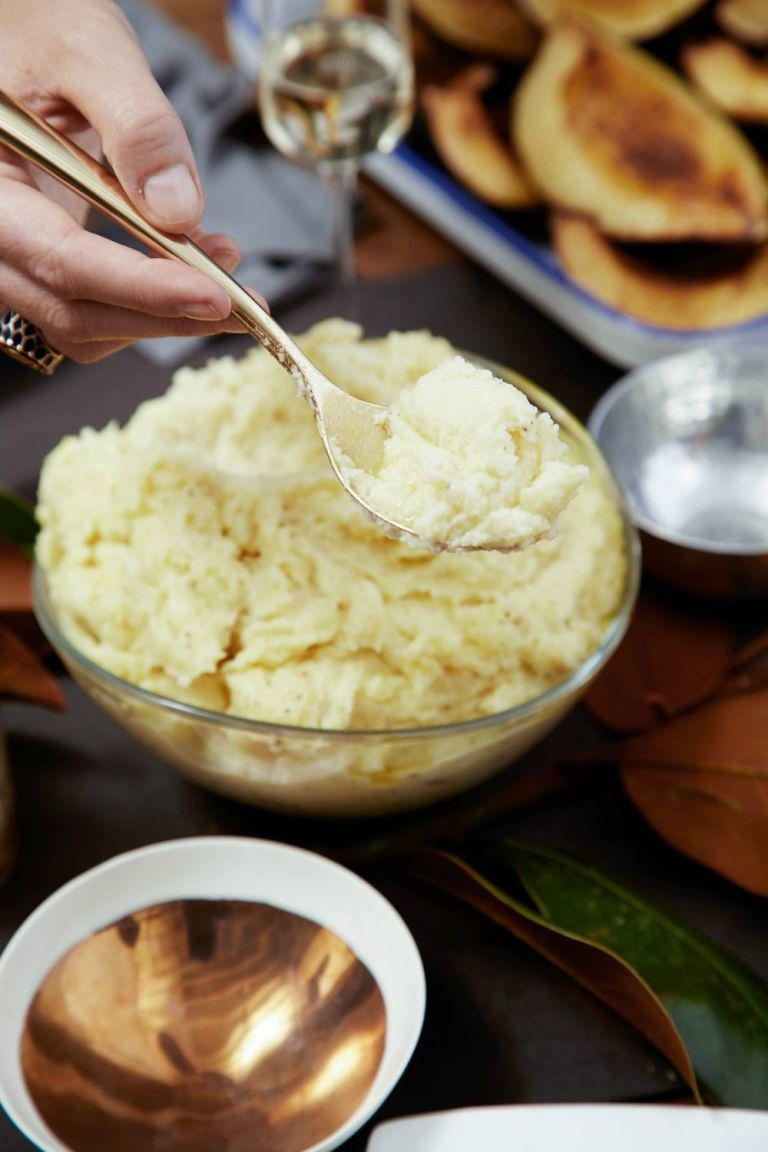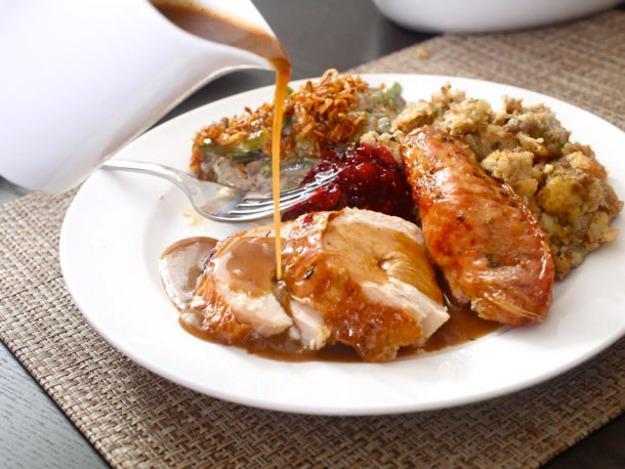The first image is the image on the left, the second image is the image on the right. Considering the images on both sides, is "A silver fork is sitting near the food in the image on the right." valid? Answer yes or no. Yes. The first image is the image on the left, the second image is the image on the right. Considering the images on both sides, is "An image shows a fork resting on a white plate of food." valid? Answer yes or no. Yes. 